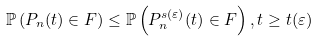Convert formula to latex. <formula><loc_0><loc_0><loc_500><loc_500>\mathbb { P } \left ( P _ { n } ( t ) \in F \right ) \leq \mathbb { P } \left ( P _ { n } ^ { s ( \varepsilon ) } ( t ) \in F \right ) , t \geq t ( \varepsilon )</formula> 